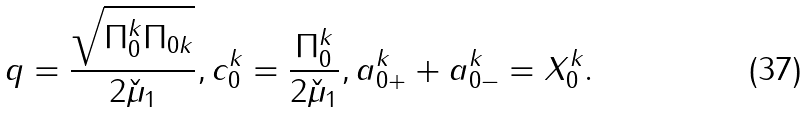Convert formula to latex. <formula><loc_0><loc_0><loc_500><loc_500>q = \frac { \sqrt { \Pi _ { 0 } ^ { k } \Pi _ { 0 k } } } { 2 \check { \mu } _ { 1 } } , c ^ { k } _ { 0 } = \frac { \Pi ^ { k } _ { 0 } } { 2 \check { \mu } _ { 1 } } , a ^ { k } _ { 0 + } + a ^ { k } _ { 0 - } = X ^ { k } _ { 0 } .</formula> 